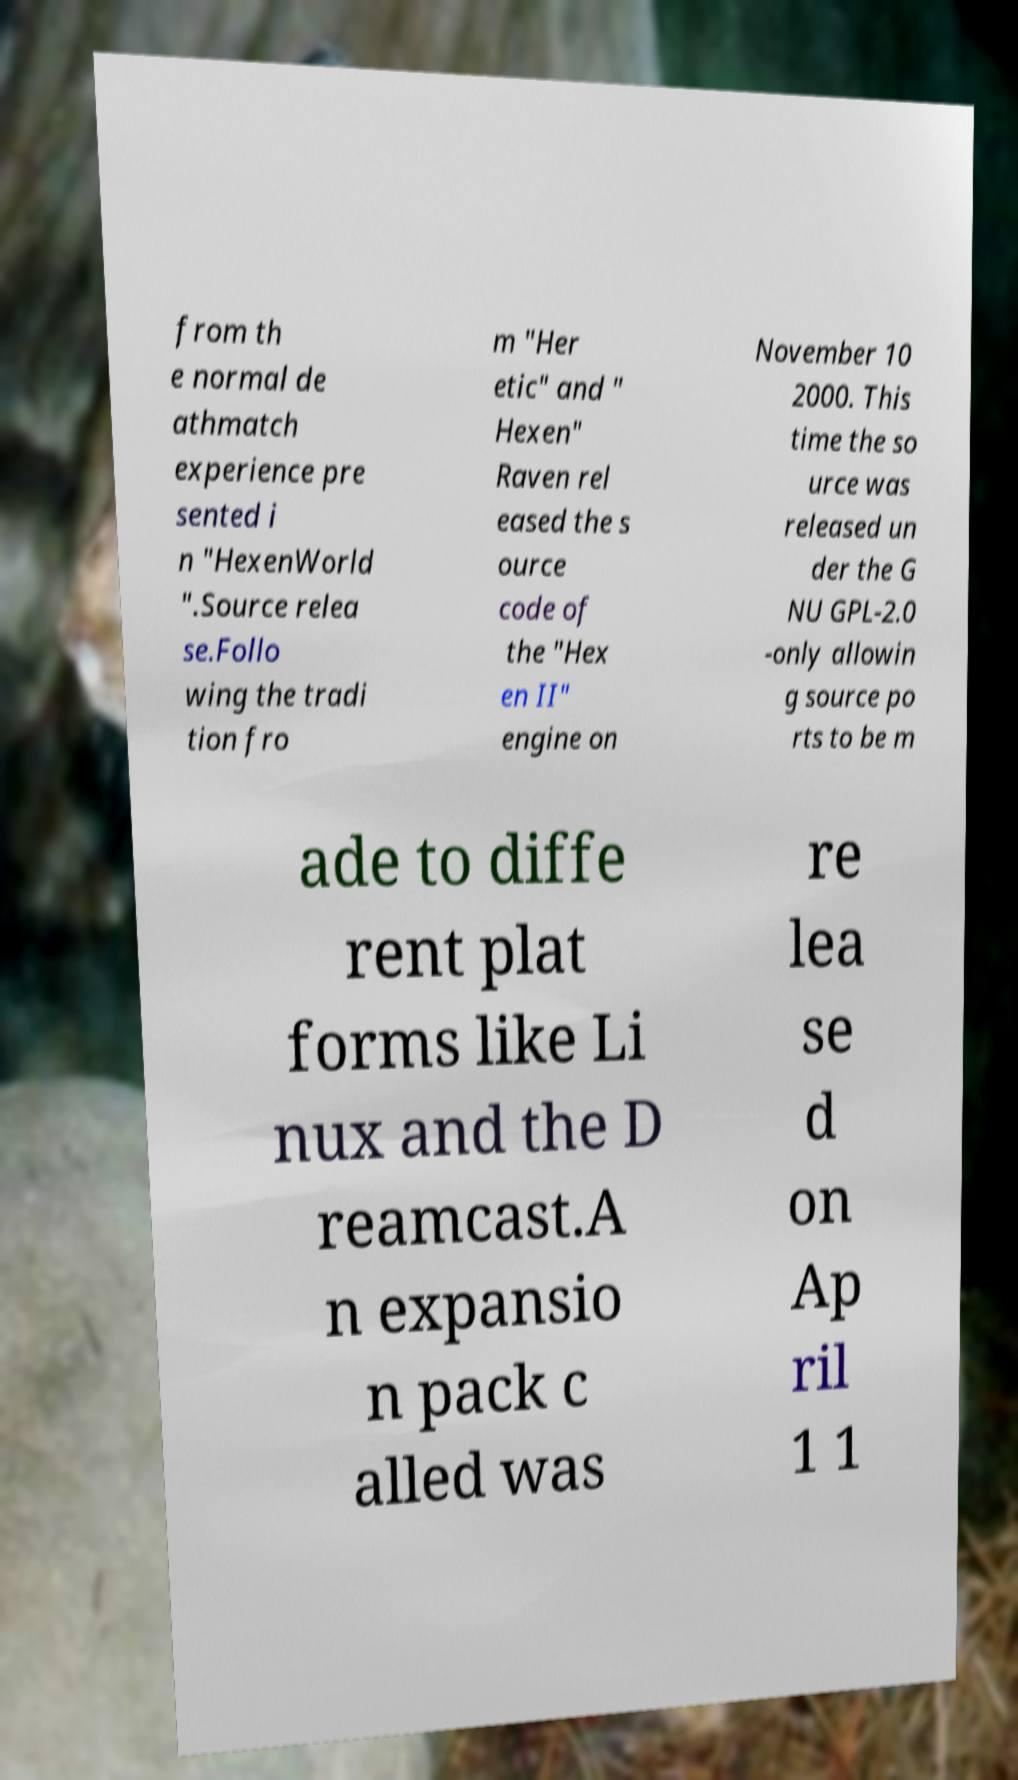There's text embedded in this image that I need extracted. Can you transcribe it verbatim? from th e normal de athmatch experience pre sented i n "HexenWorld ".Source relea se.Follo wing the tradi tion fro m "Her etic" and " Hexen" Raven rel eased the s ource code of the "Hex en II" engine on November 10 2000. This time the so urce was released un der the G NU GPL-2.0 -only allowin g source po rts to be m ade to diffe rent plat forms like Li nux and the D reamcast.A n expansio n pack c alled was re lea se d on Ap ril 1 1 